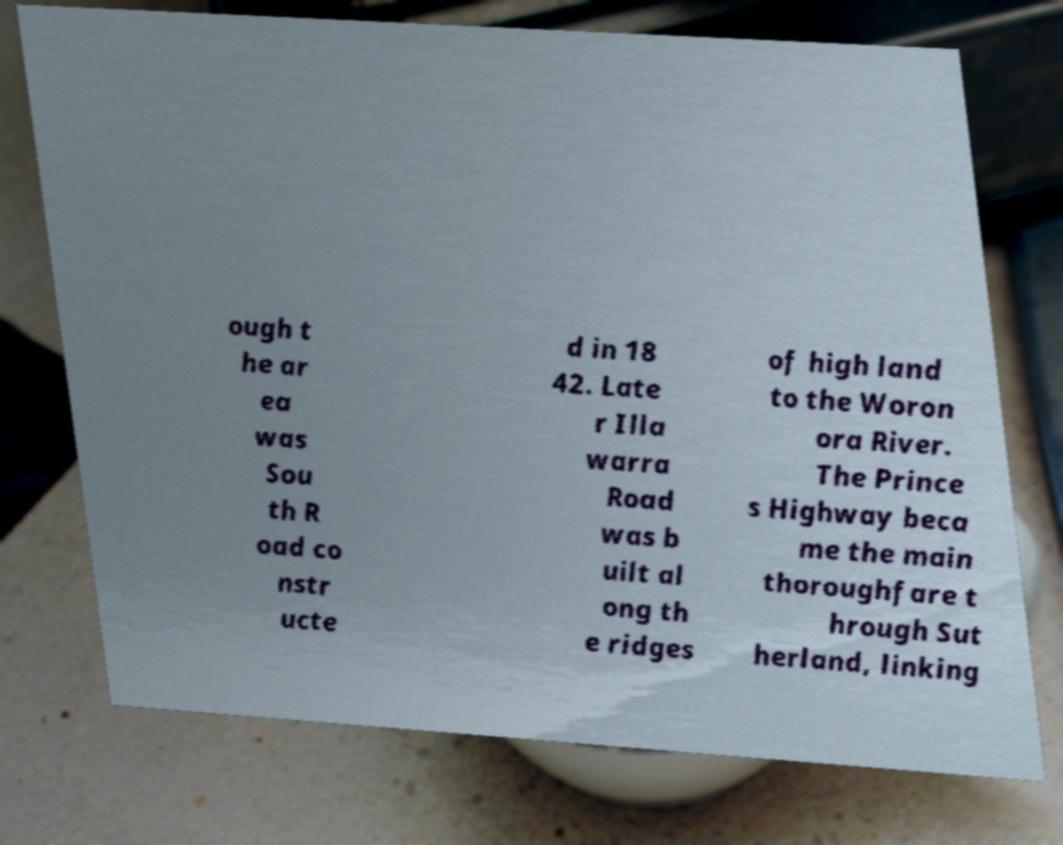Please identify and transcribe the text found in this image. ough t he ar ea was Sou th R oad co nstr ucte d in 18 42. Late r Illa warra Road was b uilt al ong th e ridges of high land to the Woron ora River. The Prince s Highway beca me the main thoroughfare t hrough Sut herland, linking 